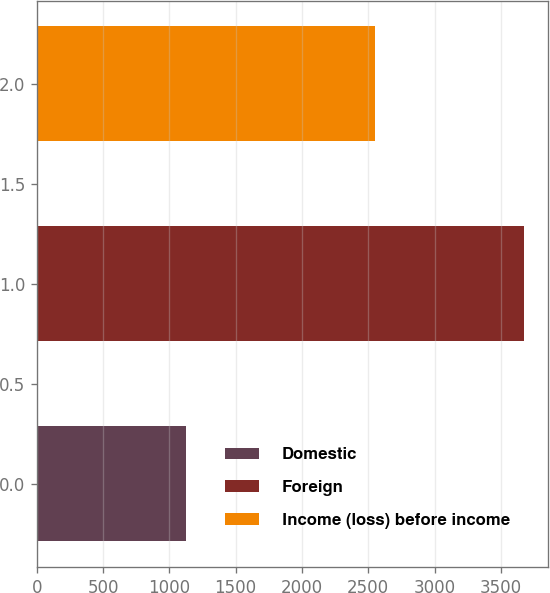Convert chart. <chart><loc_0><loc_0><loc_500><loc_500><bar_chart><fcel>Domestic<fcel>Foreign<fcel>Income (loss) before income<nl><fcel>1122<fcel>3675<fcel>2553<nl></chart> 